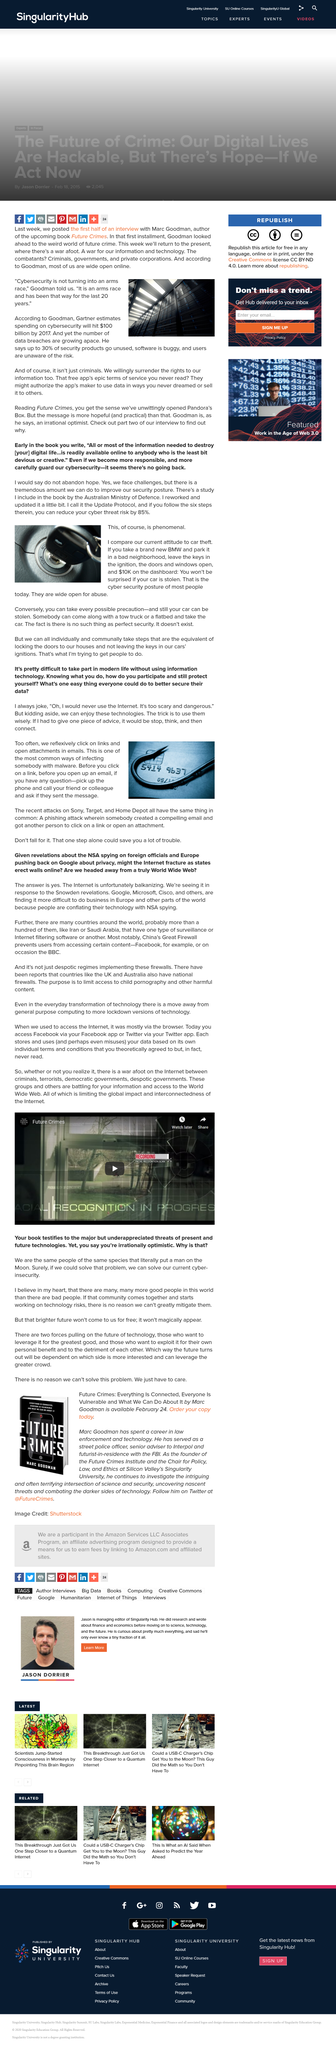Outline some significant characteristics in this image. Malware in an email is typically represented by a fish hook on a credit card. If you question a link or email, it is recommended that you contact your friend or colleague to verify if they sent the message. It is advisable to employ prudence when utilizing information technology by pausing to reflect and then making purposeful connections, as recommended. 